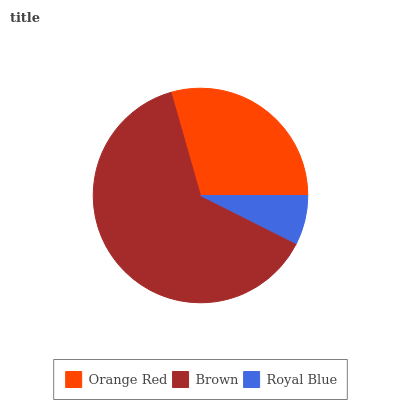Is Royal Blue the minimum?
Answer yes or no. Yes. Is Brown the maximum?
Answer yes or no. Yes. Is Brown the minimum?
Answer yes or no. No. Is Royal Blue the maximum?
Answer yes or no. No. Is Brown greater than Royal Blue?
Answer yes or no. Yes. Is Royal Blue less than Brown?
Answer yes or no. Yes. Is Royal Blue greater than Brown?
Answer yes or no. No. Is Brown less than Royal Blue?
Answer yes or no. No. Is Orange Red the high median?
Answer yes or no. Yes. Is Orange Red the low median?
Answer yes or no. Yes. Is Royal Blue the high median?
Answer yes or no. No. Is Brown the low median?
Answer yes or no. No. 